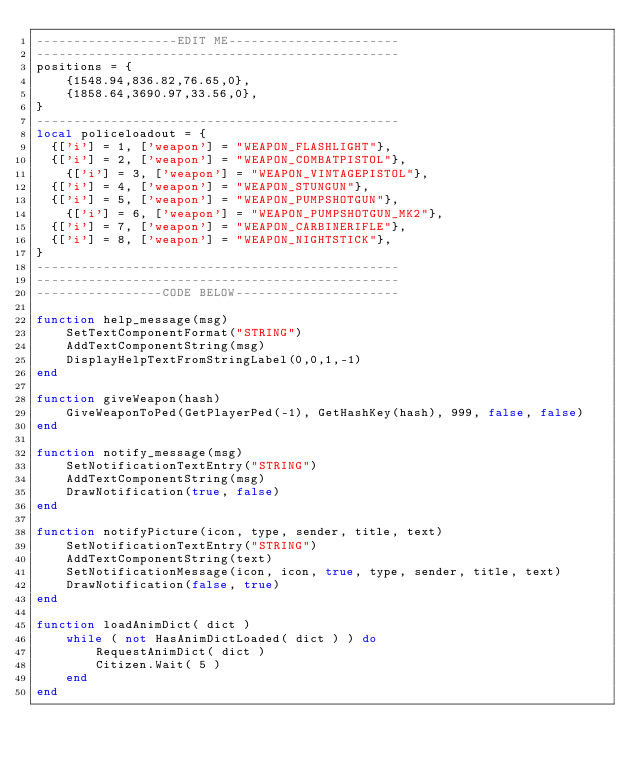Convert code to text. <code><loc_0><loc_0><loc_500><loc_500><_Lua_>-------------------EDIT ME-----------------------
-------------------------------------------------
positions = {
    {1548.94,836.82,76.65,0},
    {1858.64,3690.97,33.56,0},
}
-------------------------------------------------
local policeloadout = {
	{['i'] = 1, ['weapon'] = "WEAPON_FLASHLIGHT"},
	{['i'] = 2, ['weapon'] = "WEAPON_COMBATPISTOL"},
   	{['i'] = 3, ['weapon'] = "WEAPON_VINTAGEPISTOL"},
	{['i'] = 4, ['weapon'] = "WEAPON_STUNGUN"},
	{['i'] = 5, ['weapon'] = "WEAPON_PUMPSHOTGUN"},
    {['i'] = 6, ['weapon'] = "WEAPON_PUMPSHOTGUN_MK2"},
	{['i'] = 7, ['weapon'] = "WEAPON_CARBINERIFLE"},
	{['i'] = 8, ['weapon'] = "WEAPON_NIGHTSTICK"},
}
-------------------------------------------------
-------------------------------------------------
-----------------CODE BELOW----------------------

function help_message(msg)
    SetTextComponentFormat("STRING")
    AddTextComponentString(msg)
    DisplayHelpTextFromStringLabel(0,0,1,-1)
end

function giveWeapon(hash)
    GiveWeaponToPed(GetPlayerPed(-1), GetHashKey(hash), 999, false, false)
end

function notify_message(msg)
    SetNotificationTextEntry("STRING")
    AddTextComponentString(msg)
    DrawNotification(true, false)
end

function notifyPicture(icon, type, sender, title, text)
    SetNotificationTextEntry("STRING")
    AddTextComponentString(text)
    SetNotificationMessage(icon, icon, true, type, sender, title, text)
    DrawNotification(false, true)
end

function loadAnimDict( dict )
    while ( not HasAnimDictLoaded( dict ) ) do
        RequestAnimDict( dict )
        Citizen.Wait( 5 )
    end
end 
</code> 